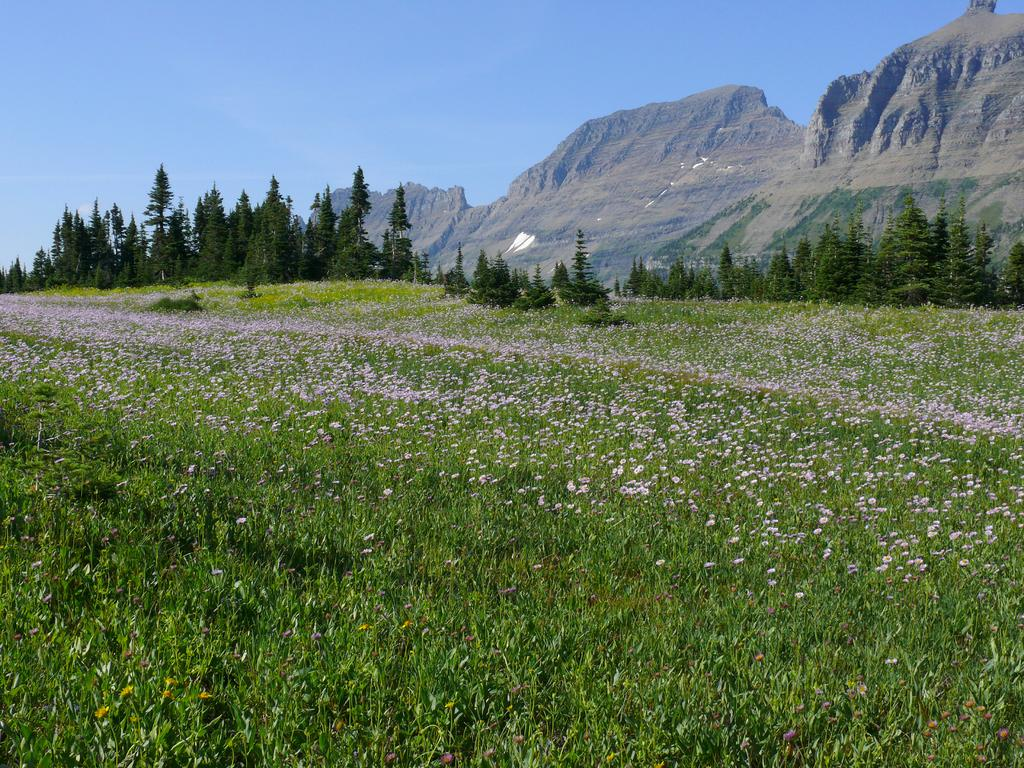Where was the picture taken? The picture was clicked outside. What can be seen in the foreground of the image? There are plants and flowers in the foreground. What is located in the center of the image? There are trees and hills in the center of the image. What is visible in the background of the image? The sky is visible in the background. What type of cord is being used to hold the trees in the image? There is no cord present in the image; the trees are standing on their own. 